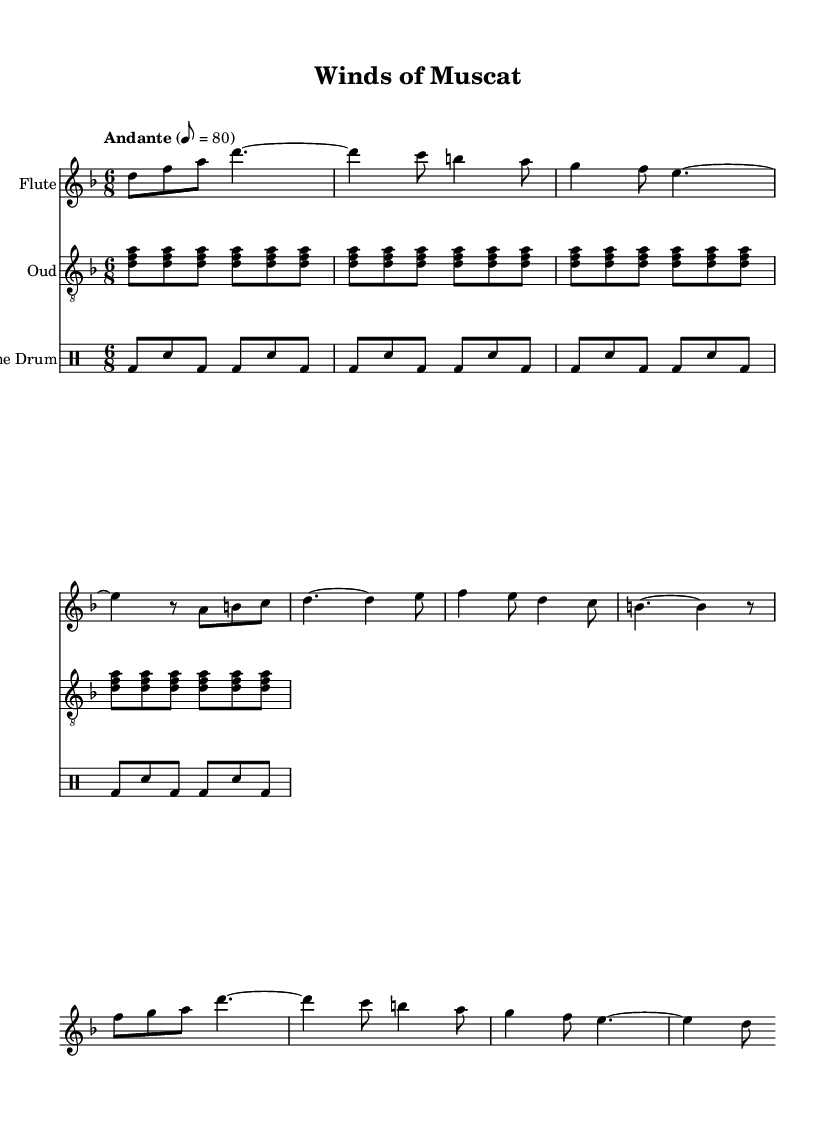What is the key signature of this music? The key signature is D minor, which is indicated by one flat (B flat). This is found at the beginning of the sheet music, right after the clef.
Answer: D minor What is the time signature of this music? The time signature is 6/8, which shows that there are six eighth notes in each measure. This can be observed at the beginning of the sheet music, immediately following the key signature.
Answer: 6/8 What is the tempo marking for this piece? The tempo marking is "Andante," signifying a moderate pace. This information is noted above the stave at the beginning of the sheet music.
Answer: Andante How many measures are there in the chorus? There are four measures in the chorus section, which can be counted directly from the musical notation provided. Each measure is separated by vertical lines in the music staff.
Answer: 4 What is the starting note of the flute part? The starting note of the flute part is D. This is determined by looking at the first note on the flute staff, which is placed on the fourth line of the treble clef.
Answer: D What instrument plays the repeating notes in the oud part? The instrument that plays the repeating notes in the oud part is the oud. This can be indicated at the start of the oud staff where it mentions "oud" as the instrument name.
Answer: Oud What type of rhythm is indicated by the frame drum notation? The rhythm indicated by the frame drum notation is a mix of bass and snare drum hits, specifically in a pattern repeated four times. The notation shows "bd" for bass drum and "sn" for snare drum in the drummode section.
Answer: Frame drum 